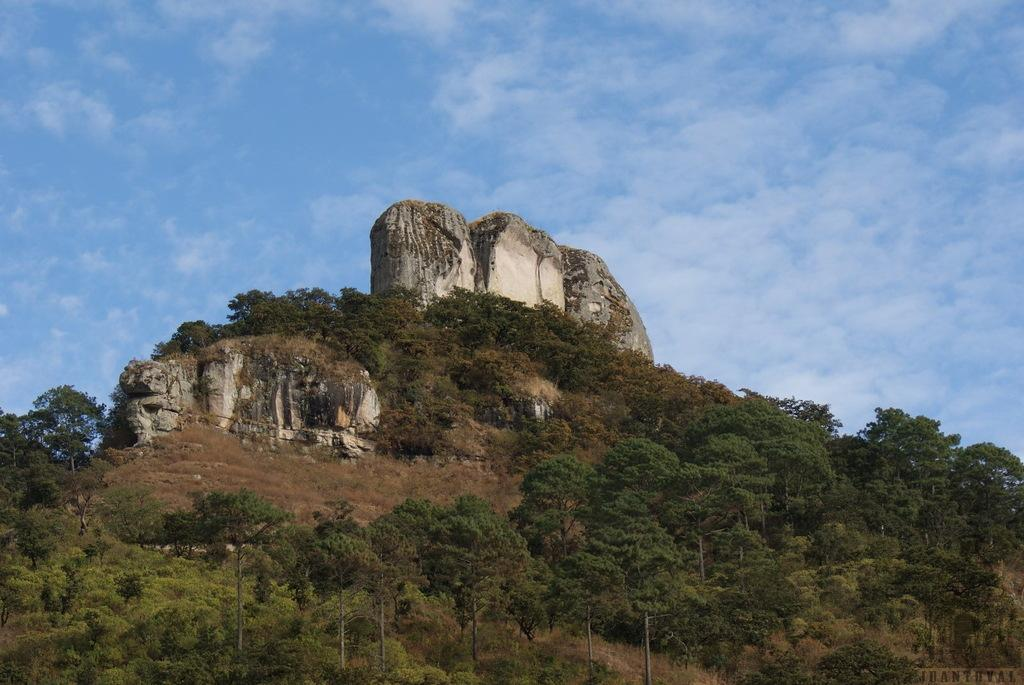What type of natural elements can be seen in the image? There are trees and a mountain in the image. What is the color of the sky in the image? The sky is blue in the image. What type of street can be seen in the image? There is no street present in the image; it features trees, a mountain, and a blue sky. What kind of record is being played in the image? There is no record or any indication of music playing in the image. 